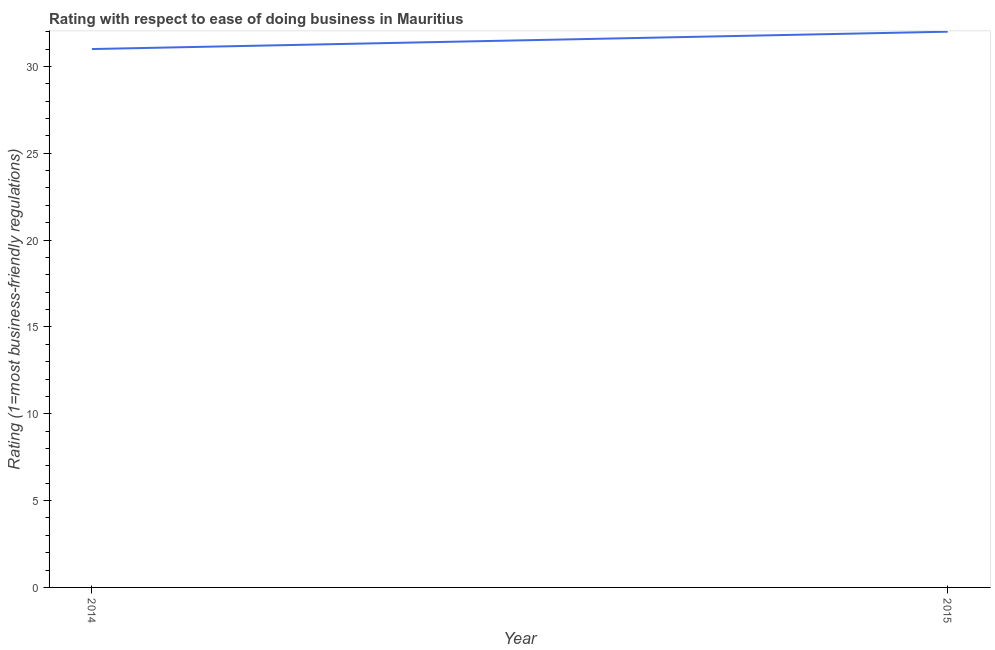What is the ease of doing business index in 2015?
Make the answer very short. 32. Across all years, what is the maximum ease of doing business index?
Provide a succinct answer. 32. Across all years, what is the minimum ease of doing business index?
Offer a very short reply. 31. In which year was the ease of doing business index maximum?
Your answer should be compact. 2015. What is the sum of the ease of doing business index?
Your answer should be compact. 63. What is the difference between the ease of doing business index in 2014 and 2015?
Make the answer very short. -1. What is the average ease of doing business index per year?
Your answer should be very brief. 31.5. What is the median ease of doing business index?
Provide a succinct answer. 31.5. What is the ratio of the ease of doing business index in 2014 to that in 2015?
Make the answer very short. 0.97. Does the ease of doing business index monotonically increase over the years?
Offer a terse response. Yes. How many lines are there?
Ensure brevity in your answer.  1. Are the values on the major ticks of Y-axis written in scientific E-notation?
Provide a short and direct response. No. Does the graph contain grids?
Offer a terse response. No. What is the title of the graph?
Give a very brief answer. Rating with respect to ease of doing business in Mauritius. What is the label or title of the X-axis?
Make the answer very short. Year. What is the label or title of the Y-axis?
Provide a succinct answer. Rating (1=most business-friendly regulations). What is the Rating (1=most business-friendly regulations) in 2014?
Keep it short and to the point. 31. What is the Rating (1=most business-friendly regulations) in 2015?
Your answer should be very brief. 32. 